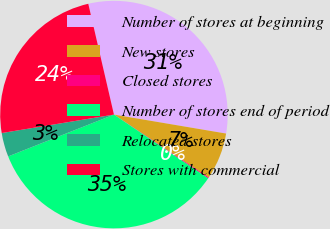Convert chart. <chart><loc_0><loc_0><loc_500><loc_500><pie_chart><fcel>Number of stores at beginning<fcel>New stores<fcel>Closed stores<fcel>Number of stores end of period<fcel>Relocated stores<fcel>Stores with commercial<nl><fcel>31.29%<fcel>6.65%<fcel>0.15%<fcel>34.54%<fcel>3.4%<fcel>23.97%<nl></chart> 